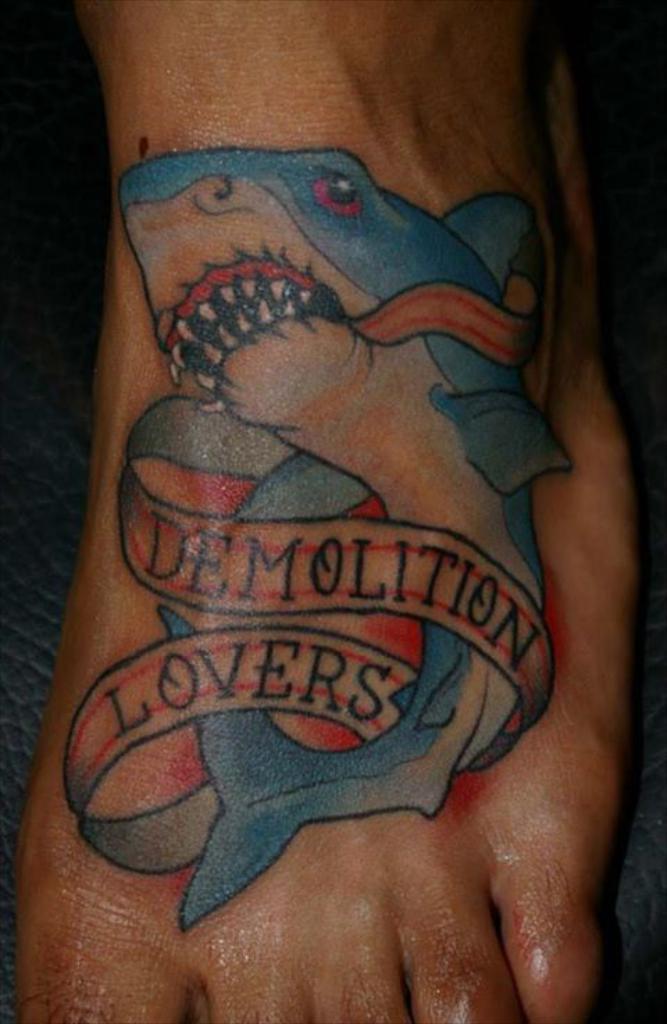Describe this image in one or two sentences. In this image I can see a person leg and a fish tattoo on the leg. It is in blue,red and black color. 